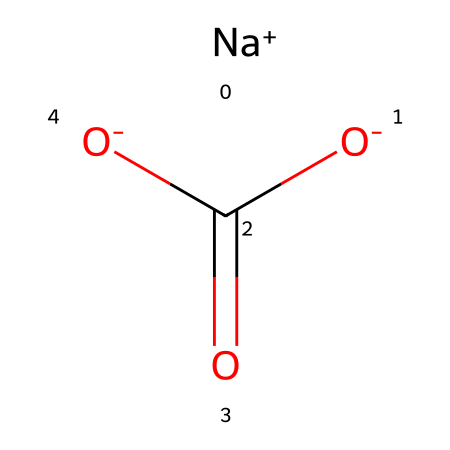What is the chemical name for the structure represented? The chemical structure is sodium bicarbonate, which is derived from the components visible in the SMILES notation - Na for sodium and the bicarbonate ion structure, which includes carbon and oxygen.
Answer: sodium bicarbonate How many carbon atoms are in the molecule? By analyzing the structure, we can see that the bicarbonate ion contains one carbon atom, which is part of the carboxylate group as indicated in the SMILES notation.
Answer: one What type of ion is sodium in this structure? The sodium ion is represented as [Na+], indicating that it has a positive charge, thus categorizing it as a cation in the molecule.
Answer: cation How many total oxygen atoms are present in the structure? Counting the oxygen atoms shown in the SMILES representation, there are three oxygen atoms associated with the bicarbonate ion - two from the carboxylate group and one bound to the sodium ion.
Answer: three Does sodium bicarbonate contain any acidic properties? The presence of the bicarbonate ion (HCO3-) indicates that it can act as a weak acid in solutions, contributing to its acidic properties.
Answer: yes What is the total charge of the sodium bicarbonate structure? Since sodium carries a +1 charge and the bicarbonate carries a -1 charge (sum total of the charges: +1 - 1 = 0), the entire molecule is electrically neutral.
Answer: zero 